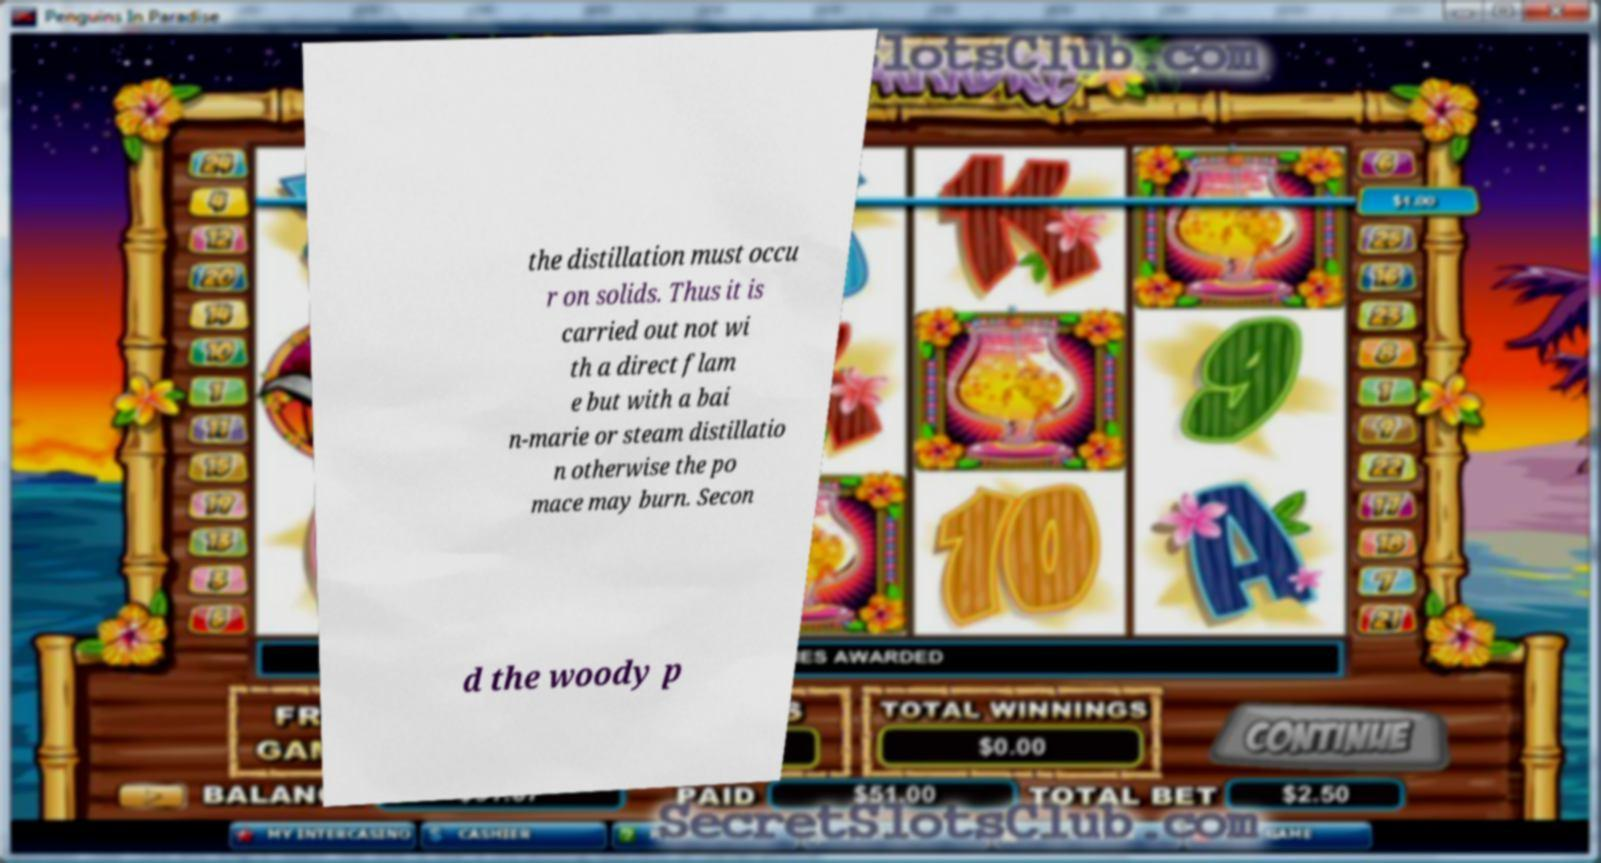Could you extract and type out the text from this image? the distillation must occu r on solids. Thus it is carried out not wi th a direct flam e but with a bai n-marie or steam distillatio n otherwise the po mace may burn. Secon d the woody p 